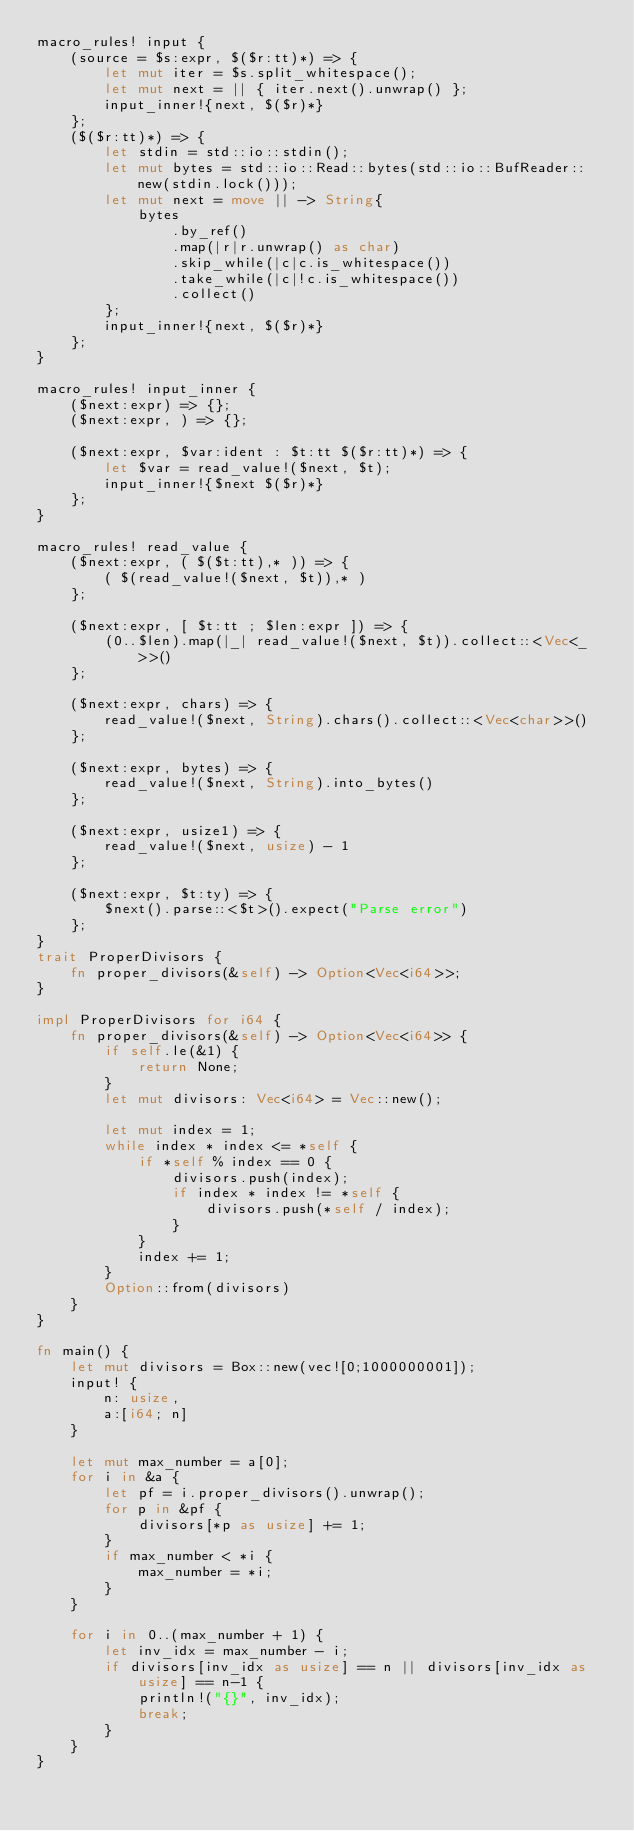<code> <loc_0><loc_0><loc_500><loc_500><_Rust_>macro_rules! input {
    (source = $s:expr, $($r:tt)*) => {
        let mut iter = $s.split_whitespace();
        let mut next = || { iter.next().unwrap() };
        input_inner!{next, $($r)*}
    };
    ($($r:tt)*) => {
        let stdin = std::io::stdin();
        let mut bytes = std::io::Read::bytes(std::io::BufReader::new(stdin.lock()));
        let mut next = move || -> String{
            bytes
                .by_ref()
                .map(|r|r.unwrap() as char)
                .skip_while(|c|c.is_whitespace())
                .take_while(|c|!c.is_whitespace())
                .collect()
        };
        input_inner!{next, $($r)*}
    };
}

macro_rules! input_inner {
    ($next:expr) => {};
    ($next:expr, ) => {};

    ($next:expr, $var:ident : $t:tt $($r:tt)*) => {
        let $var = read_value!($next, $t);
        input_inner!{$next $($r)*}
    };
}

macro_rules! read_value {
    ($next:expr, ( $($t:tt),* )) => {
        ( $(read_value!($next, $t)),* )
    };

    ($next:expr, [ $t:tt ; $len:expr ]) => {
        (0..$len).map(|_| read_value!($next, $t)).collect::<Vec<_>>()
    };

    ($next:expr, chars) => {
        read_value!($next, String).chars().collect::<Vec<char>>()
    };

    ($next:expr, bytes) => {
        read_value!($next, String).into_bytes()
    };

    ($next:expr, usize1) => {
        read_value!($next, usize) - 1
    };

    ($next:expr, $t:ty) => {
        $next().parse::<$t>().expect("Parse error")
    };
}
trait ProperDivisors {
    fn proper_divisors(&self) -> Option<Vec<i64>>;
}
 
impl ProperDivisors for i64 {
    fn proper_divisors(&self) -> Option<Vec<i64>> {
        if self.le(&1) {
            return None;
        }
        let mut divisors: Vec<i64> = Vec::new();
 
        let mut index = 1;
        while index * index <= *self {
            if *self % index == 0 {
                divisors.push(index);
                if index * index != *self {
                    divisors.push(*self / index);
                }
            }
            index += 1;
        }
        Option::from(divisors)
    }
}

fn main() {
    let mut divisors = Box::new(vec![0;1000000001]);
    input! {
        n: usize,
        a:[i64; n]
    }

    let mut max_number = a[0];
    for i in &a {
        let pf = i.proper_divisors().unwrap();
        for p in &pf {
            divisors[*p as usize] += 1;
        }
        if max_number < *i {
            max_number = *i;
        }
    }

    for i in 0..(max_number + 1) {
        let inv_idx = max_number - i;
        if divisors[inv_idx as usize] == n || divisors[inv_idx as usize] == n-1 {
            println!("{}", inv_idx);
            break;
        }
    }
}

</code> 